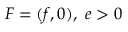<formula> <loc_0><loc_0><loc_500><loc_500>F = ( f , 0 ) , \ e > 0</formula> 